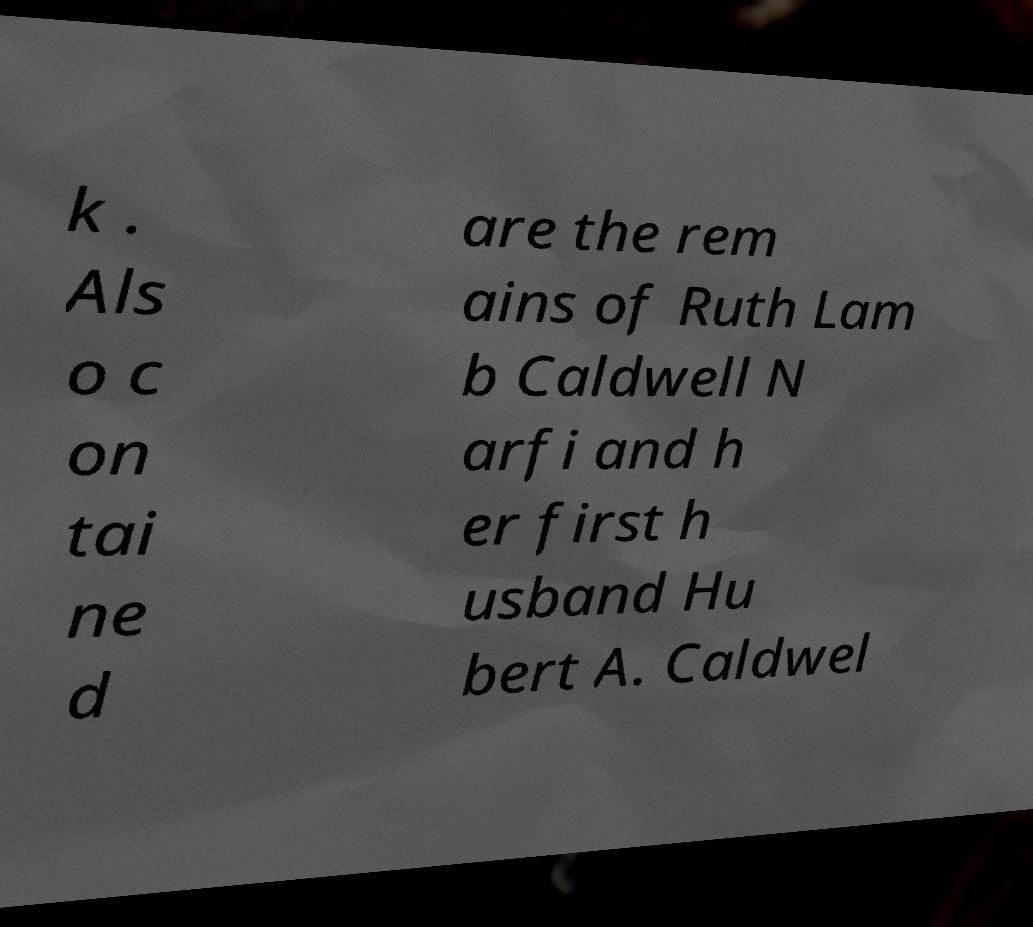Can you read and provide the text displayed in the image?This photo seems to have some interesting text. Can you extract and type it out for me? k . Als o c on tai ne d are the rem ains of Ruth Lam b Caldwell N arfi and h er first h usband Hu bert A. Caldwel 